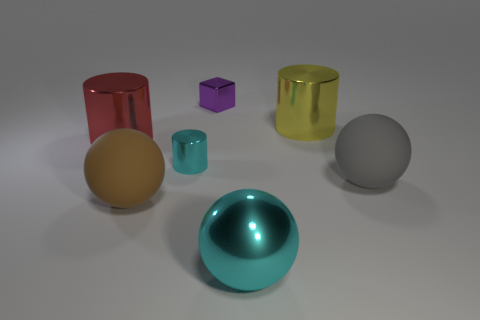Do the tiny cyan cylinder and the big sphere on the right side of the big yellow object have the same material?
Your response must be concise. No. There is a cyan thing that is the same shape as the big yellow thing; what material is it?
Offer a terse response. Metal. Are there any other things that have the same material as the large red object?
Provide a short and direct response. Yes. Does the ball to the right of the yellow shiny cylinder have the same material as the cylinder that is left of the tiny cyan thing?
Offer a terse response. No. What is the color of the cylinder left of the big matte object to the left of the cyan shiny object in front of the brown ball?
Your answer should be compact. Red. How many other things are there of the same shape as the large brown thing?
Provide a short and direct response. 2. Do the metallic sphere and the tiny cylinder have the same color?
Your answer should be very brief. Yes. How many things are large cyan balls or metal things on the right side of the small cyan metallic cylinder?
Offer a terse response. 3. Is there a yellow object of the same size as the brown matte ball?
Your answer should be very brief. Yes. Does the big gray thing have the same material as the large cyan thing?
Offer a very short reply. No. 